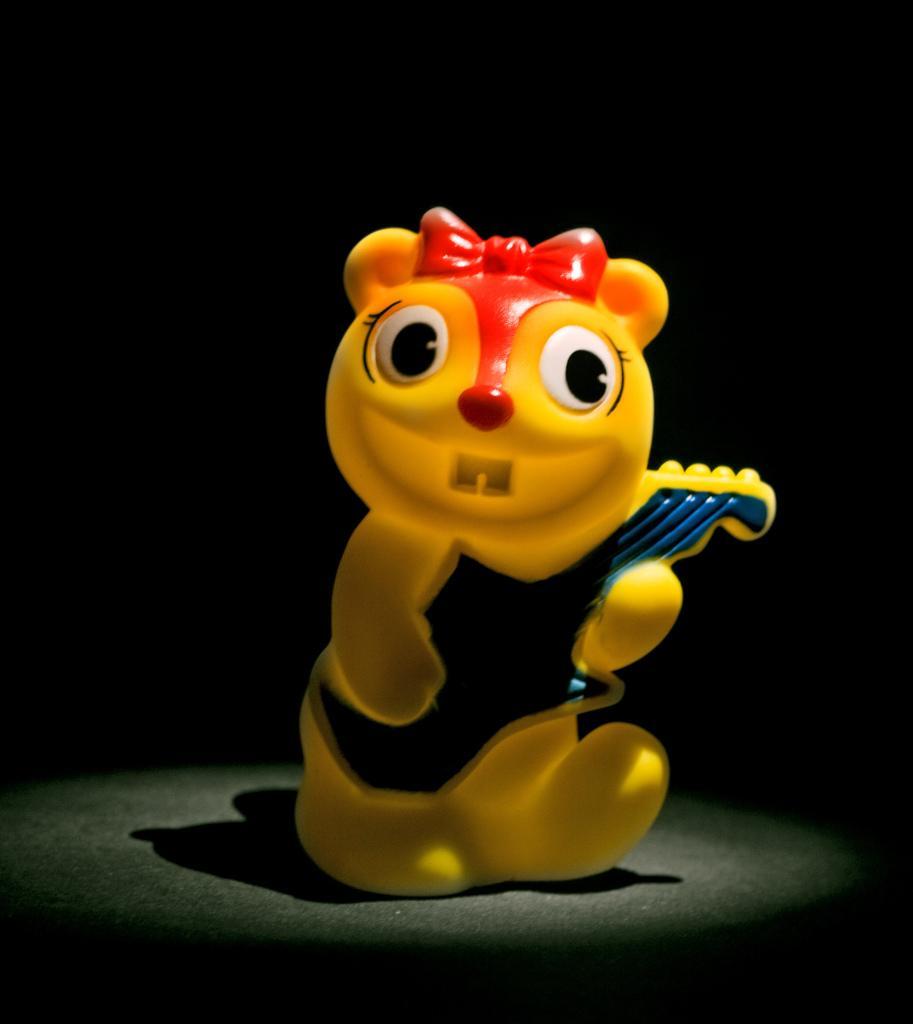Could you give a brief overview of what you see in this image? In the center of the image there is a toy on the surface. 